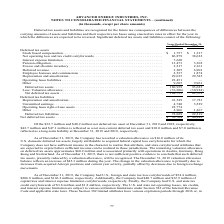According to Advanced Energy's financial document, How much was reflected as a long-term liability in 2018? According to the financial document, $7.0 million (in millions). The relevant text states: "n-current deferred tax asset and $10.0 million and $7.0 million is reflected as a long-term liability at December 31, 2019 and 2018, respectively...." Also, What was the stock based compensation in 2019? According to the financial document, $1,757 (in thousands). The relevant text states: "Stock based compensation . $ 1,757 $ 1,337..." Also, What was the Net operating loss and tax credit carryforwards in 2018? According to the financial document, 38,622 (in thousands). The relevant text states: "rating loss and tax credit carryforwards . 86,879 38,622 Interest expense limitation . 7,620 — Pension obligation. . 13,473 3,302 Excess and obsolete invent..." Also, can you calculate: What was the change in pension obligation between 2018 and 2019? Based on the calculation: 13,473-3,302, the result is 10171 (in thousands). This is based on the information: "limitation . 7,620 — Pension obligation. . 13,473 3,302 Excess and obsolete inventory . 3,217 2,161 Deferred revenue . 3,305 6,903 Employee bonuses and com xpense limitation . 7,620 — Pension obligati..." The key data points involved are: 13,473, 3,302. Also, can you calculate: What was the change in Excess and obsolete inventory between 2018 and 2019? Based on the calculation: 3,217-2,161, the result is 1056 (in thousands). This is based on the information: "3,473 3,302 Excess and obsolete inventory . 3,217 2,161 Deferred revenue . 3,305 6,903 Employee bonuses and commissions . 2,537 1,874 Depreciation and amor n. . 13,473 3,302 Excess and obsolete invent..." The key data points involved are: 2,161, 3,217. Also, can you calculate: What was the percentage change in Net deferred tax assets between 2018 and 2019? To answer this question, I need to perform calculations using the financial data. The calculation is: ($32,704-$40,242)/$40,242, which equals -18.73 (percentage). This is based on the information: "Net deferred tax assets . $ 32,704 $ 40,242 Of the $32.7 million and $40.2 million net deferred tax asset at December 31, 2019 and 2018, respec Net deferred tax assets . $ 32,704 $ 40,242 Of the $32.7..." The key data points involved are: 32,704, 40,242. 